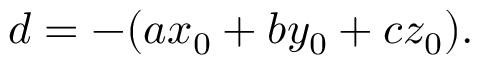Convert formula to latex. <formula><loc_0><loc_0><loc_500><loc_500>d = - ( a x _ { 0 } + b y _ { 0 } + c z _ { 0 } ) .</formula> 